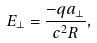<formula> <loc_0><loc_0><loc_500><loc_500>E _ { \perp } = \frac { - q a _ { \perp } } { c ^ { 2 } R } ,</formula> 